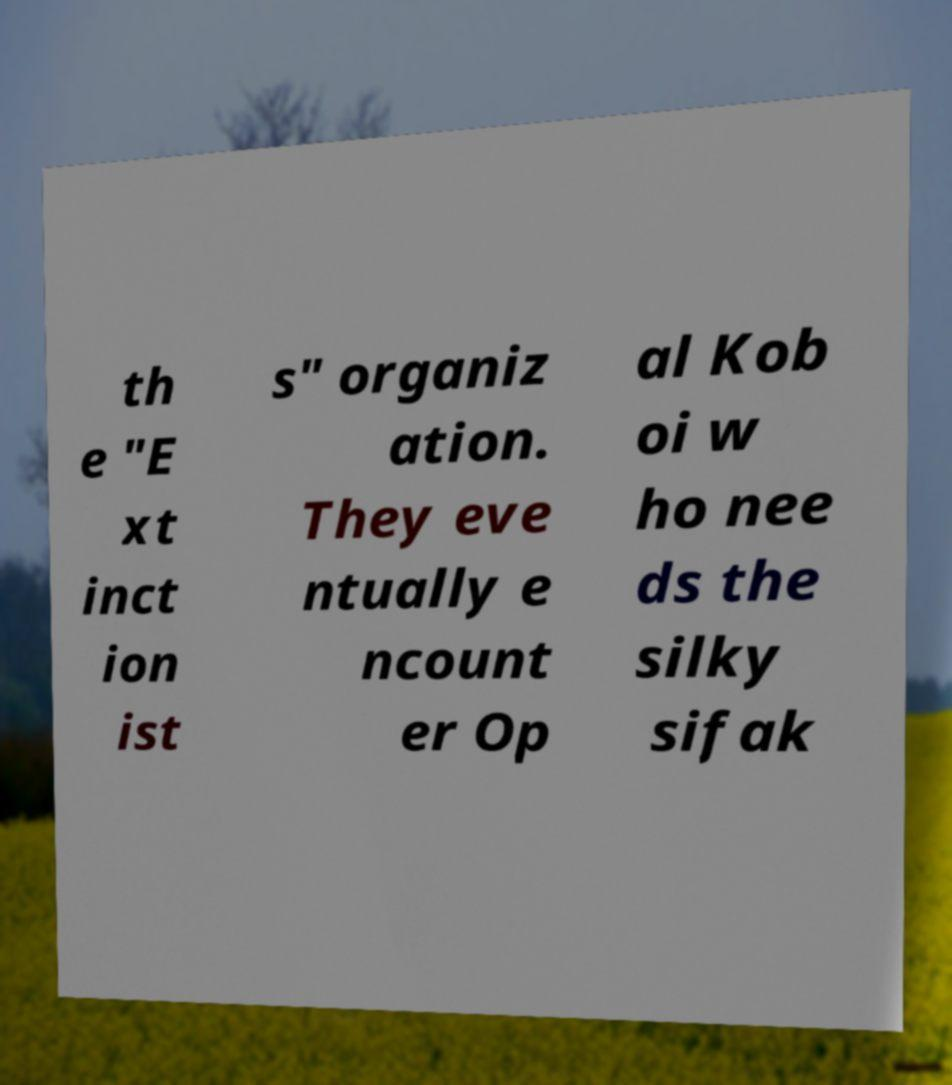What messages or text are displayed in this image? I need them in a readable, typed format. th e "E xt inct ion ist s" organiz ation. They eve ntually e ncount er Op al Kob oi w ho nee ds the silky sifak 